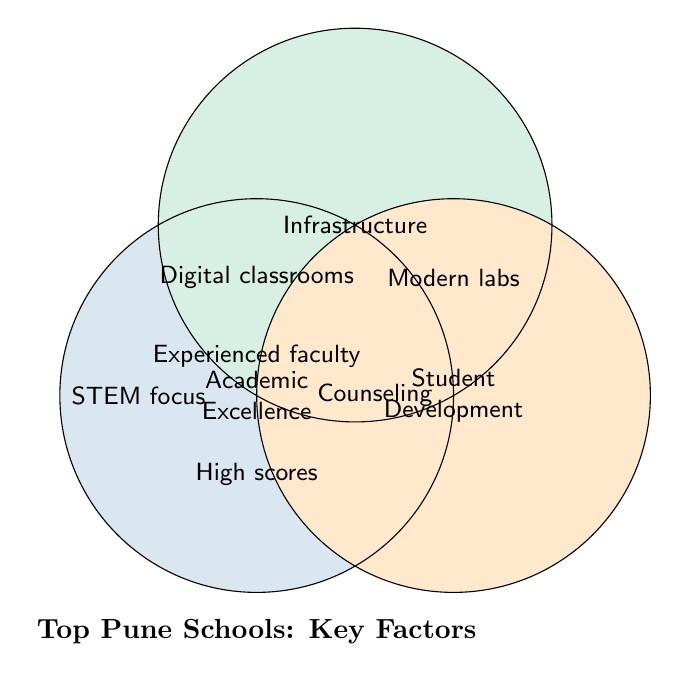What are the main categories represented in the Venn Diagram? The main categories are mentioned inside the three main circles.
Answer: Academic Excellence, Infrastructure, Student Development How many factors overlap between Academic Excellence and Infrastructure? The only overlapping factor mentioned at the intersection of Academic Excellence and Infrastructure is "Digital classrooms."
Answer: 1 Which category has a factor related to STEM focus? The factor "STEM focus" is located inside the circle of Academic Excellence.
Answer: Academic Excellence What is a common factor between all three categories? The factor in the overlapping region of all three circles is "Experienced faculty."
Answer: Experienced faculty Which category has "Counseling” as a factor? The factor "Counseling" is inside the Student Development circle.
Answer: Student Development How many factors are present within the Infrastructure category, including overlaps? By counting, the factors inside and overlapping with Infrastructure are "Modern labs" and "Digital classrooms."
Answer: 2 What factor is unique to the Infrastructure category? The factor "Modern labs" appears to be specific to the Infrastructure category.
Answer: Modern labs How many overlapping regions are present among the three categories? By observing the intersections, there are three overlapping regions: one between each pair of categories and one among all three categories.
Answer: 3 Which factor is mentioned in the intersection of Academic Excellence and Student Development? In the overlapping region between Academic Excellence and Student Development, the factor mentioned is "High scores."
Answer: High scores 